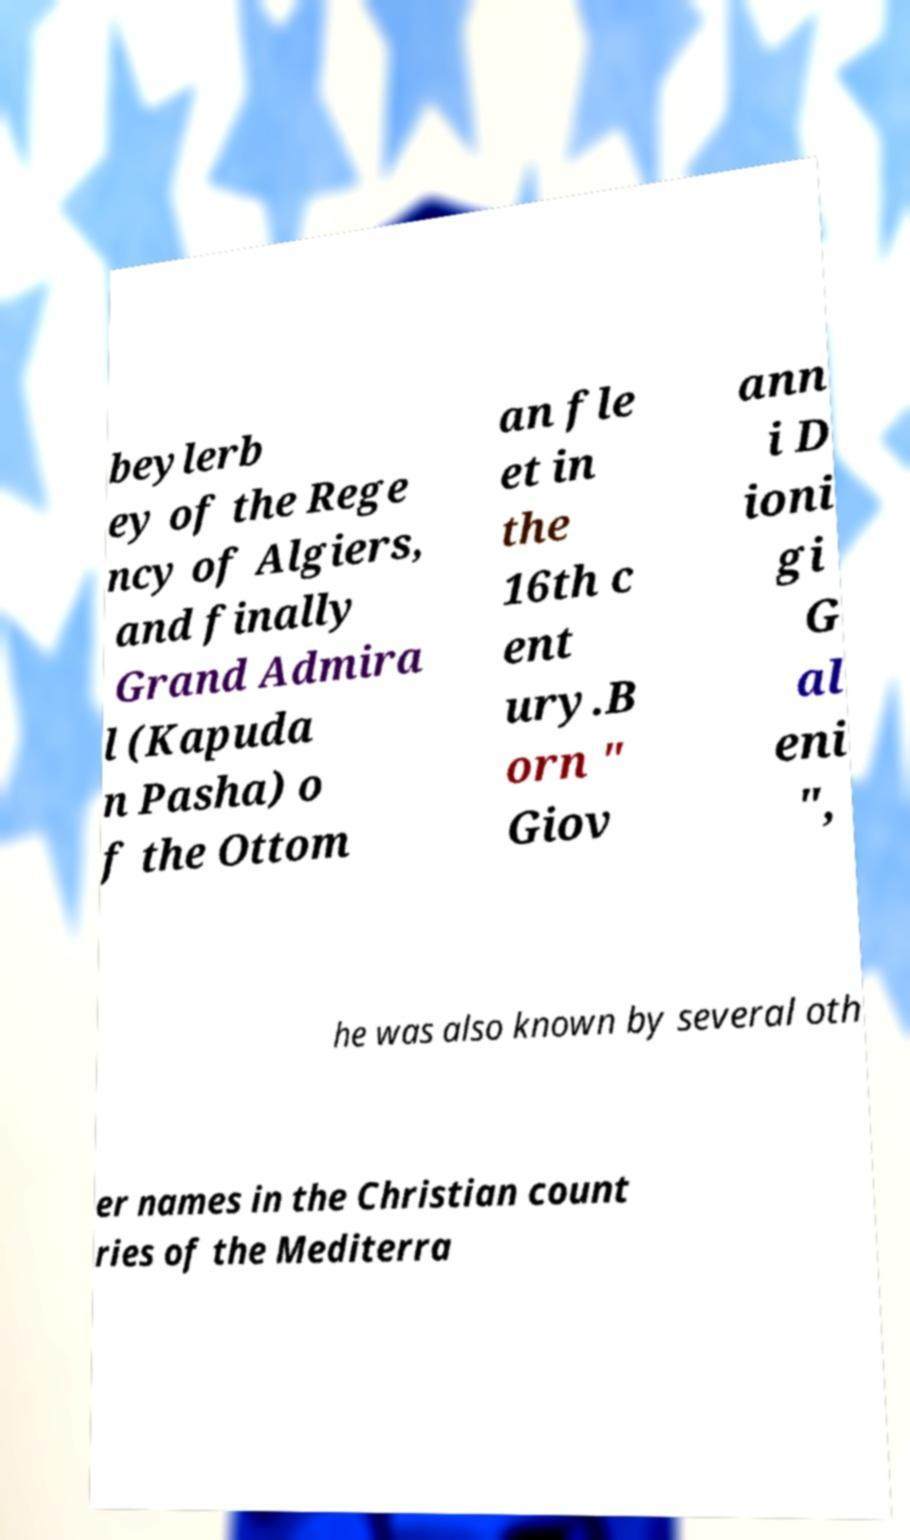Please identify and transcribe the text found in this image. beylerb ey of the Rege ncy of Algiers, and finally Grand Admira l (Kapuda n Pasha) o f the Ottom an fle et in the 16th c ent ury.B orn " Giov ann i D ioni gi G al eni ", he was also known by several oth er names in the Christian count ries of the Mediterra 